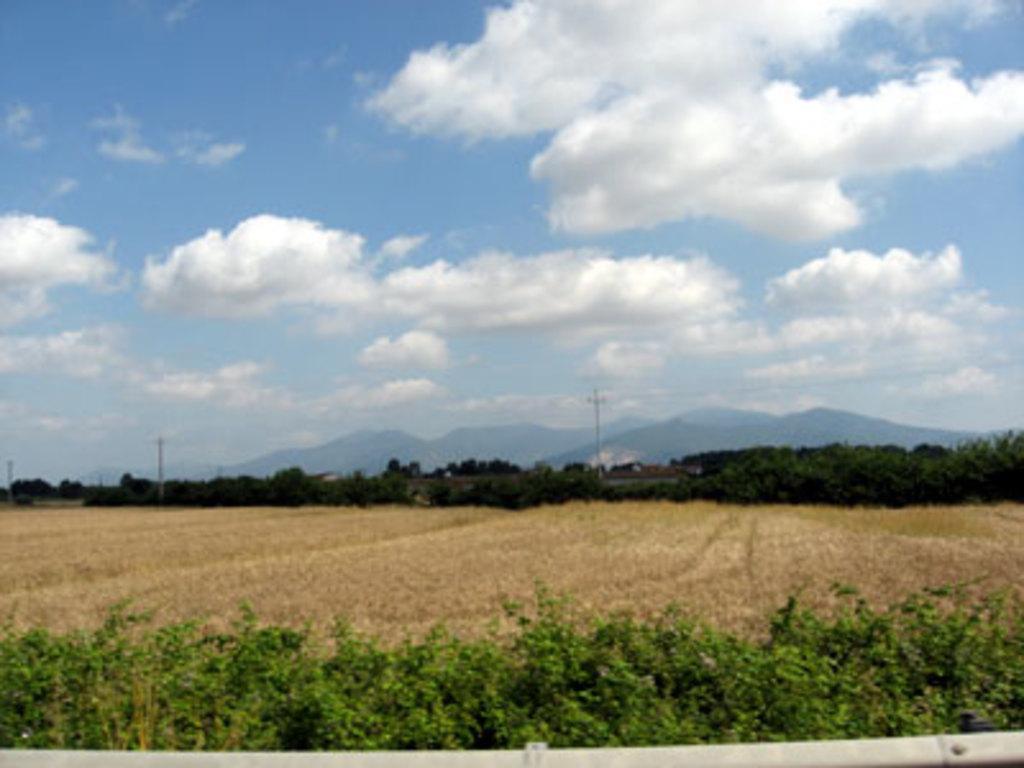Describe this image in one or two sentences. There is a pipe. In the background, there are plants having green color leaves, there are trees, mountains, poles which are having electric lines and there are clouds in the blue sky. 